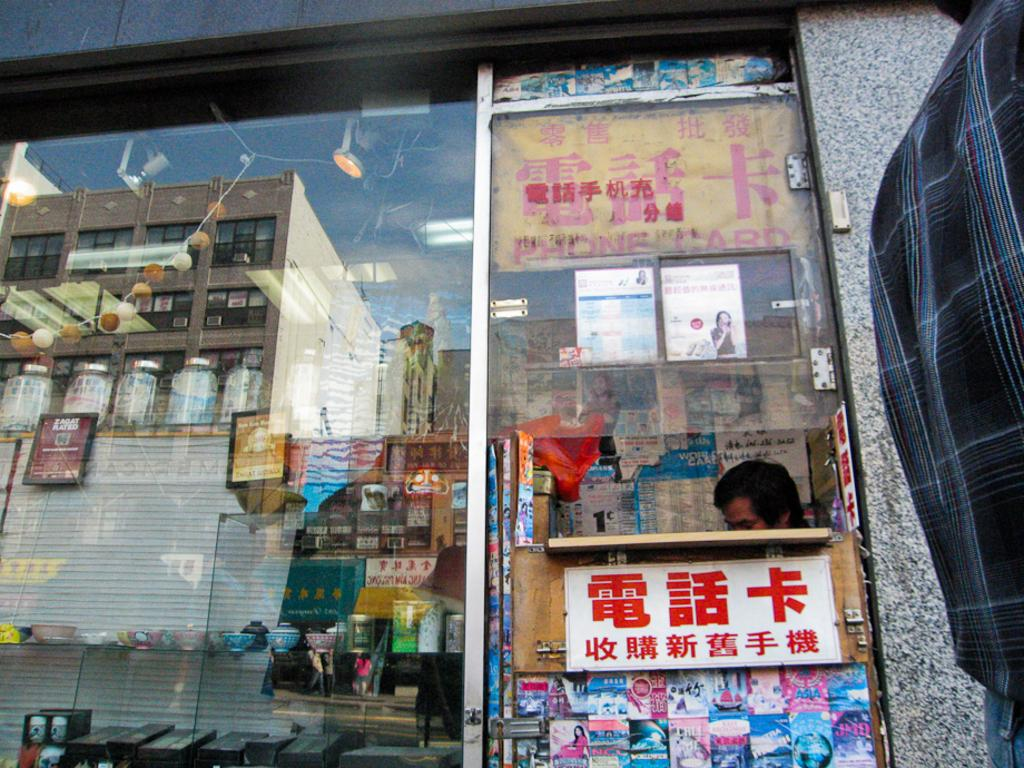Provide a one-sentence caption for the provided image. A person sits behind a counter beneath a sign advertising PHONE CARD. 